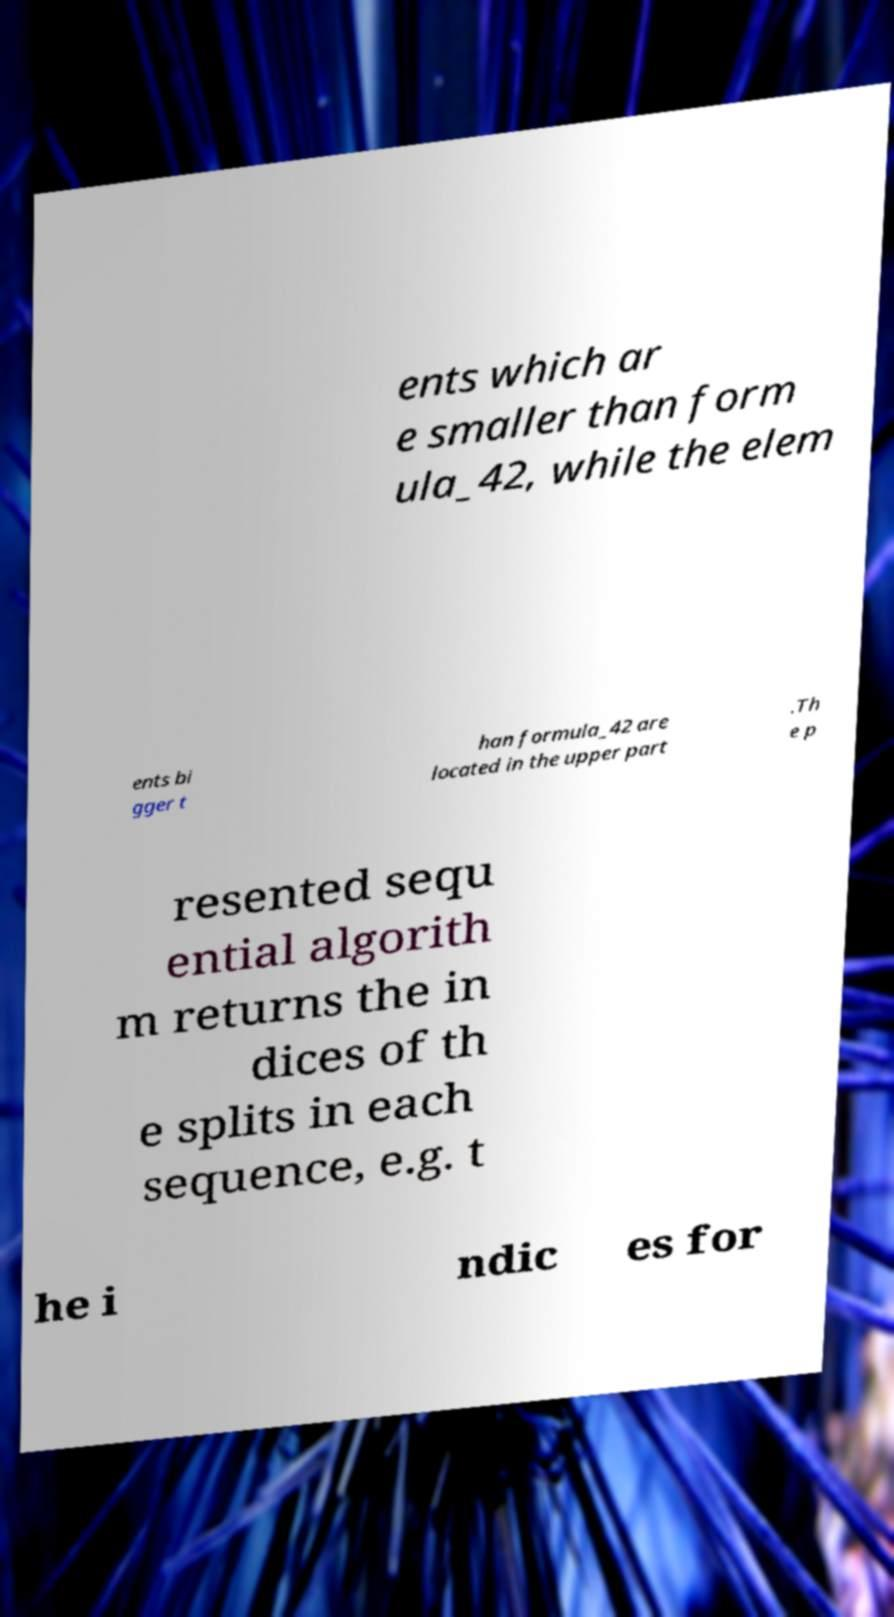Can you accurately transcribe the text from the provided image for me? ents which ar e smaller than form ula_42, while the elem ents bi gger t han formula_42 are located in the upper part .Th e p resented sequ ential algorith m returns the in dices of th e splits in each sequence, e.g. t he i ndic es for 